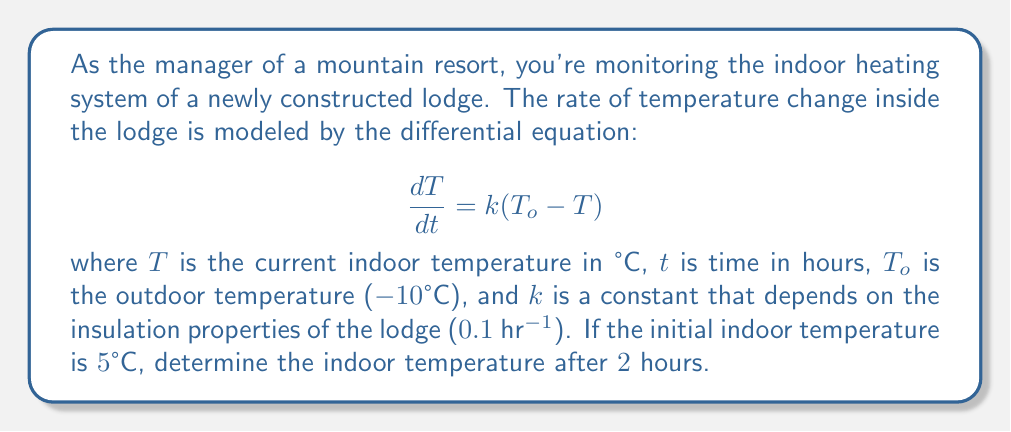Help me with this question. To solve this problem, we need to use the solution to the first-order linear differential equation:

1) The general solution to the equation $\frac{dT}{dt} = k(T_o - T)$ is:

   $$T(t) = T_o + (T_i - T_o)e^{-kt}$$

   where $T_i$ is the initial temperature.

2) We're given the following values:
   - $T_o = -10°C$ (outdoor temperature)
   - $k = 0.1$ hr⁻¹
   - $T_i = 5°C$ (initial indoor temperature)
   - $t = 2$ hours

3) Let's substitute these values into our solution:

   $$T(2) = -10 + (5 - (-10))e^{-0.1(2)}$$

4) Simplify:
   $$T(2) = -10 + 15e^{-0.2}$$

5) Calculate $e^{-0.2}$:
   $$e^{-0.2} \approx 0.8187$$

6) Now we can finish our calculation:
   $$T(2) = -10 + 15(0.8187) = -10 + 12.2805 = 2.2805°C$$

7) Rounding to two decimal places:
   $$T(2) \approx 2.28°C$$
Answer: The indoor temperature after 2 hours will be approximately 2.28°C. 